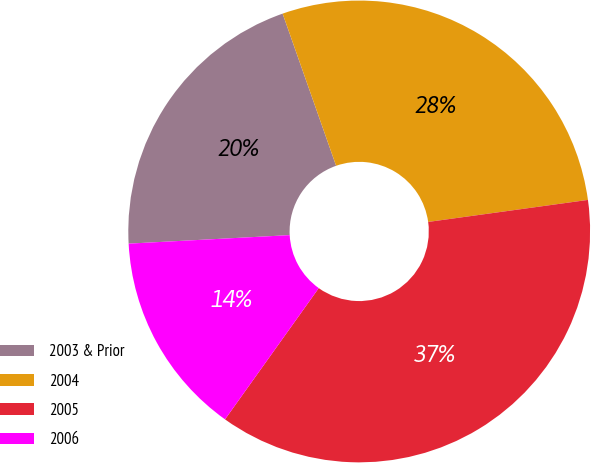Convert chart to OTSL. <chart><loc_0><loc_0><loc_500><loc_500><pie_chart><fcel>2003 & Prior<fcel>2004<fcel>2005<fcel>2006<nl><fcel>20.46%<fcel>28.2%<fcel>37.05%<fcel>14.29%<nl></chart> 